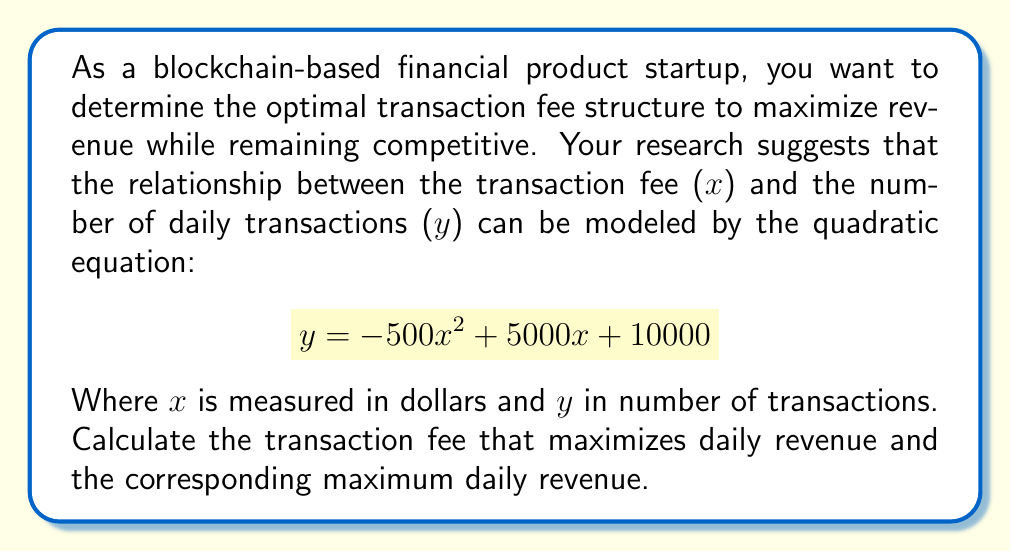What is the answer to this math problem? To solve this problem, we need to follow these steps:

1) The revenue function $R(x)$ is the product of the fee per transaction and the number of transactions:

   $$ R(x) = x \cdot y = x(-500x^2 + 5000x + 10000) $$

2) Expand this equation:

   $$ R(x) = -500x^3 + 5000x^2 + 10000x $$

3) To find the maximum revenue, we need to find where the derivative of $R(x)$ equals zero:

   $$ R'(x) = -1500x^2 + 10000x + 10000 $$

4) Set $R'(x) = 0$ and solve for $x$:

   $$ -1500x^2 + 10000x + 10000 = 0 $$

5) This is a quadratic equation. We can solve it using the quadratic formula:

   $$ x = \frac{-b \pm \sqrt{b^2 - 4ac}}{2a} $$

   Where $a = -1500$, $b = 10000$, and $c = 10000$

6) Plugging in these values:

   $$ x = \frac{-10000 \pm \sqrt{100000000 - 4(-1500)(10000)}}{2(-1500)} $$
   $$ = \frac{-10000 \pm \sqrt{160000000}}{-3000} $$
   $$ = \frac{-10000 \pm 12649.11}{-3000} $$

7) This gives us two solutions:
   $x_1 = 7.55$ and $x_2 = 0.78$

8) The second derivative of $R(x)$ is:
   $$ R''(x) = -3000x + 10000 $$

   At $x = 7.55$, $R''(7.55) = -12650 < 0$, indicating a maximum.
   At $x = 0.78$, $R''(0.78) = 7660 > 0$, indicating a minimum.

9) Therefore, the maximum revenue occurs at $x = 7.55$.

10) To find the maximum daily revenue, we plug $x = 7.55$ back into the original revenue function:

    $$ R(7.55) = -500(7.55)^3 + 5000(7.55)^2 + 10000(7.55) = 38,831.64 $$
Answer: The optimal transaction fee is $7.55, which results in a maximum daily revenue of $38,831.64. 